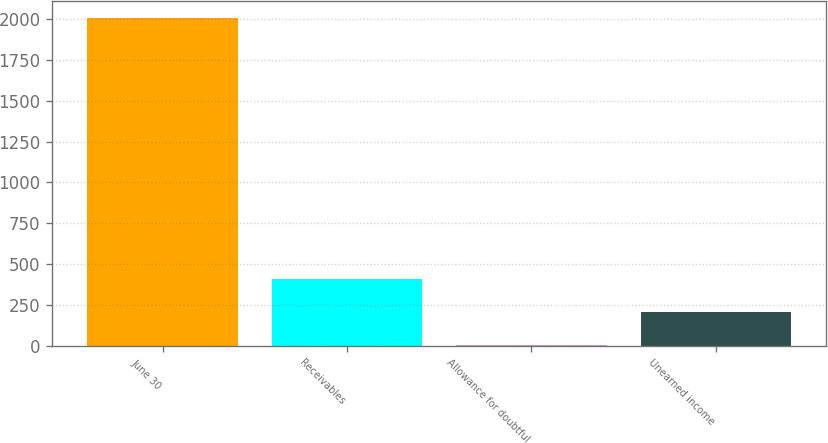<chart> <loc_0><loc_0><loc_500><loc_500><bar_chart><fcel>June 30<fcel>Receivables<fcel>Allowance for doubtful<fcel>Unearned income<nl><fcel>2008<fcel>407.92<fcel>7.9<fcel>207.91<nl></chart> 